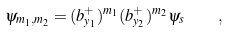<formula> <loc_0><loc_0><loc_500><loc_500>\psi _ { m _ { 1 } , m _ { 2 } } = ( b _ { y _ { 1 } } ^ { + } ) ^ { m _ { 1 } } ( b _ { y _ { 2 } } ^ { + } ) ^ { m _ { 2 } } \psi _ { s } \quad ,</formula> 